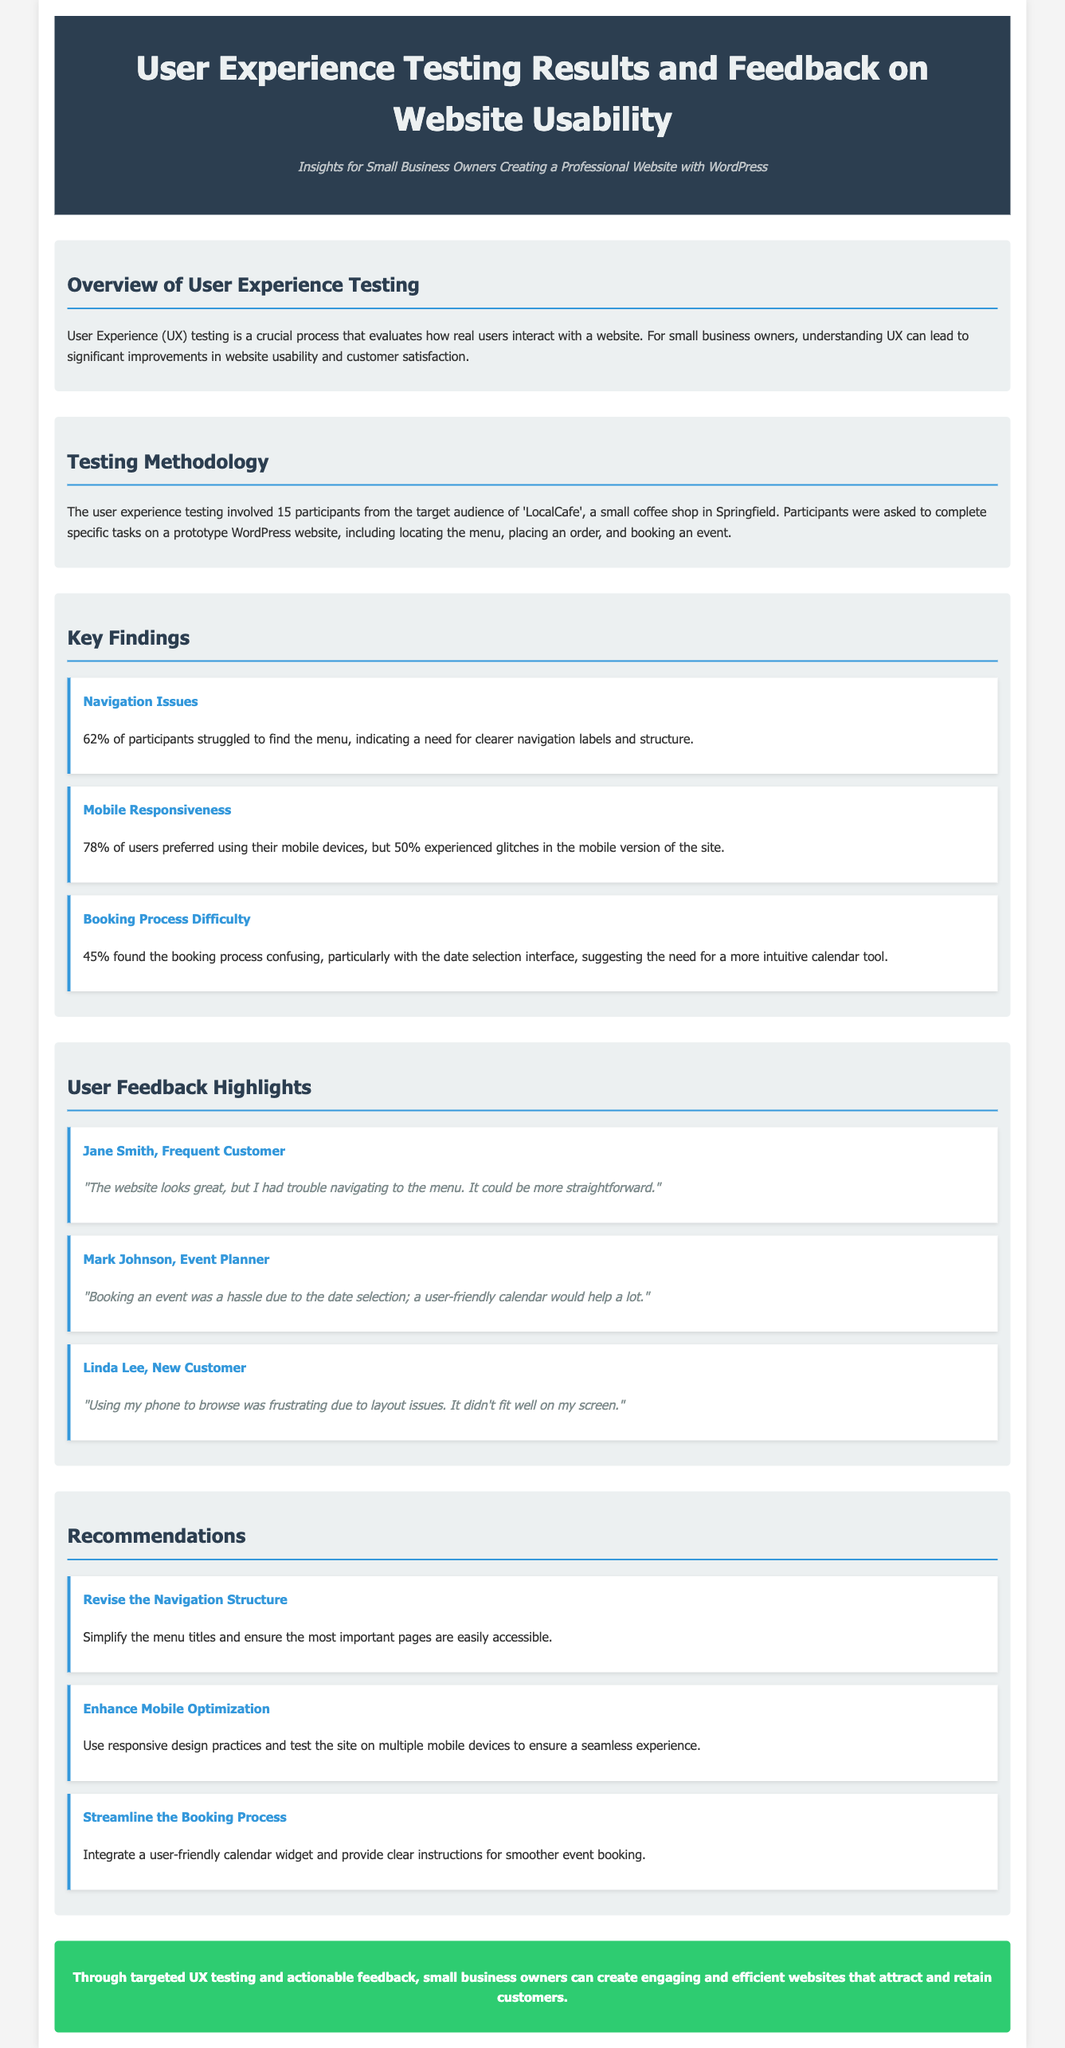What percentage of participants struggled to find the menu? The document states that 62% of participants struggled to find the menu, which reflects a navigation issue.
Answer: 62% How many participants were involved in the testing? The user experience testing involved 15 participants from the target audience of 'LocalCafe'.
Answer: 15 What specific device preference did 78% of users have? The document mentions that 78% of users preferred using their mobile devices for browsing the site.
Answer: Mobile devices What was the primary issue with the booking process according to 45% of participants? The booking process was found confusing, particularly with the date selection interface, indicating a need for improvement.
Answer: Date selection interface Which user suggested enhancing the calendar tool for booking events? Mark Johnson, an event planner, provided feedback regarding the booking difficulties and suggested a user-friendly calendar.
Answer: Mark Johnson What color is used for the header background? The header background is a dark color, specifically #2c3e50, mentioned in the document.
Answer: Dark color What main recommendation is given to improve mobile website performance? One of the recommendations is to use responsive design practices and test the site on multiple mobile devices.
Answer: Responsive design What emotion did Jane Smith express regarding the website's navigation? Jane Smith commented that the navigation could be more straightforward and experienced difficulty finding the menu.
Answer: Difficulty Which section highlights user feedback? The section titled "User Feedback Highlights" presents the impressions and comments from the participants about the website usability.
Answer: User Feedback Highlights 